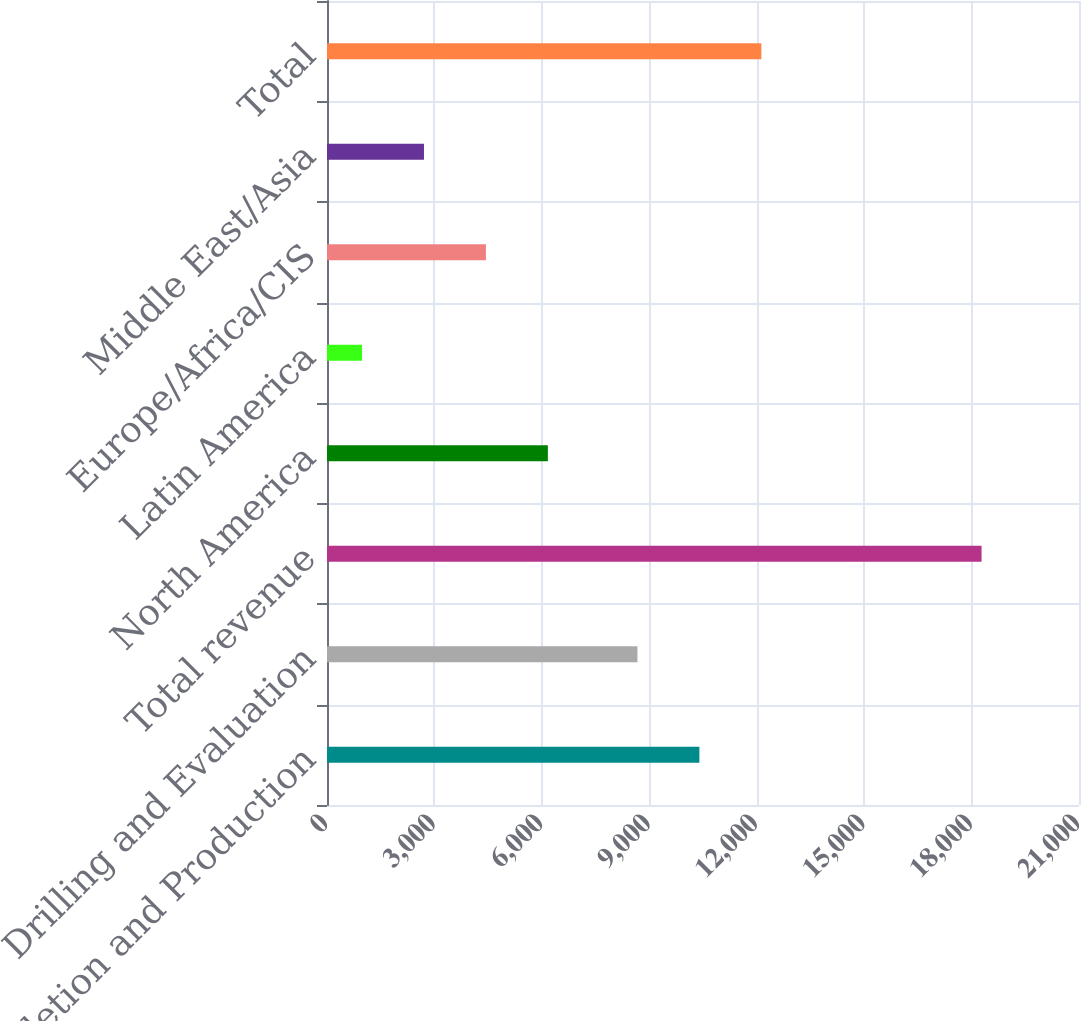Convert chart. <chart><loc_0><loc_0><loc_500><loc_500><bar_chart><fcel>Completion and Production<fcel>Drilling and Evaluation<fcel>Total revenue<fcel>North America<fcel>Latin America<fcel>Europe/Africa/CIS<fcel>Middle East/Asia<fcel>Total<nl><fcel>10399.1<fcel>8669<fcel>18279<fcel>6168.3<fcel>978<fcel>4438.2<fcel>2708.1<fcel>12129.2<nl></chart> 